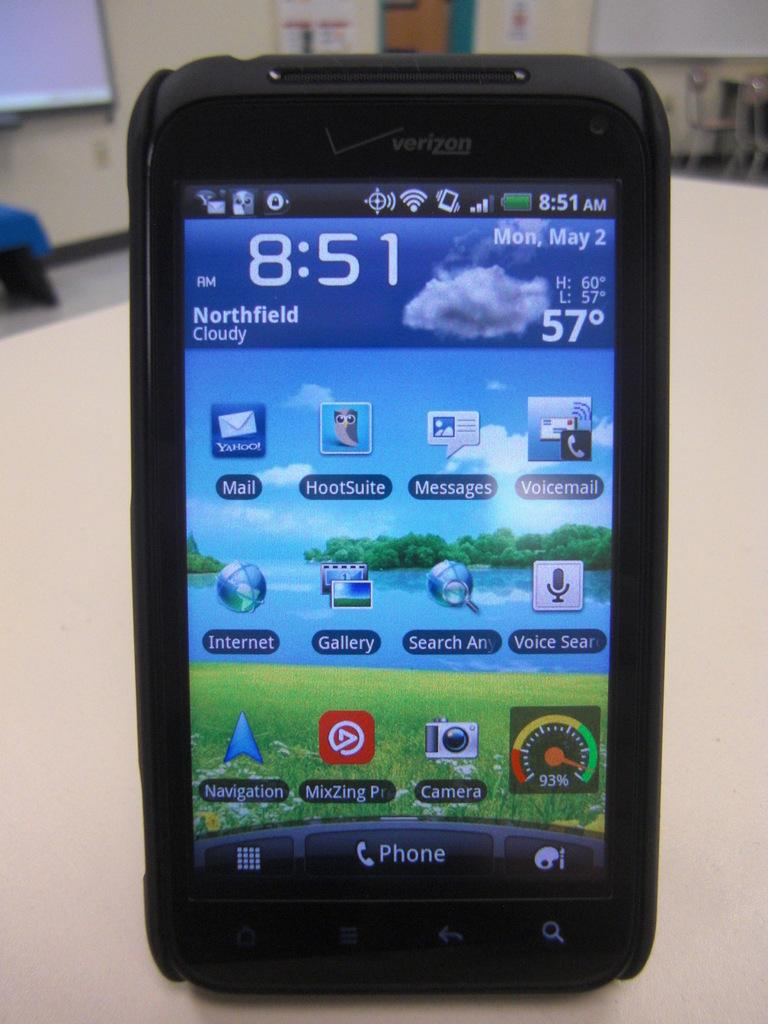<image>
Provide a brief description of the given image. a black verizon branded phone that says 'northfield cloudy' on it 